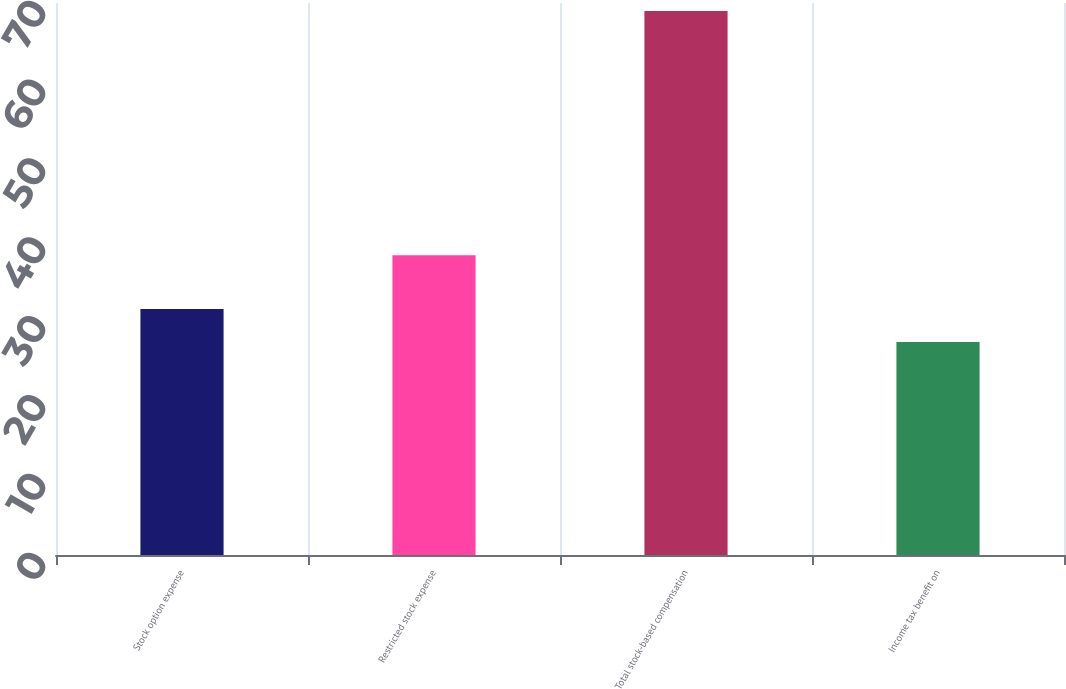<chart> <loc_0><loc_0><loc_500><loc_500><bar_chart><fcel>Stock option expense<fcel>Restricted stock expense<fcel>Total stock-based compensation<fcel>Income tax benefit on<nl><fcel>31.2<fcel>38<fcel>69<fcel>27<nl></chart> 